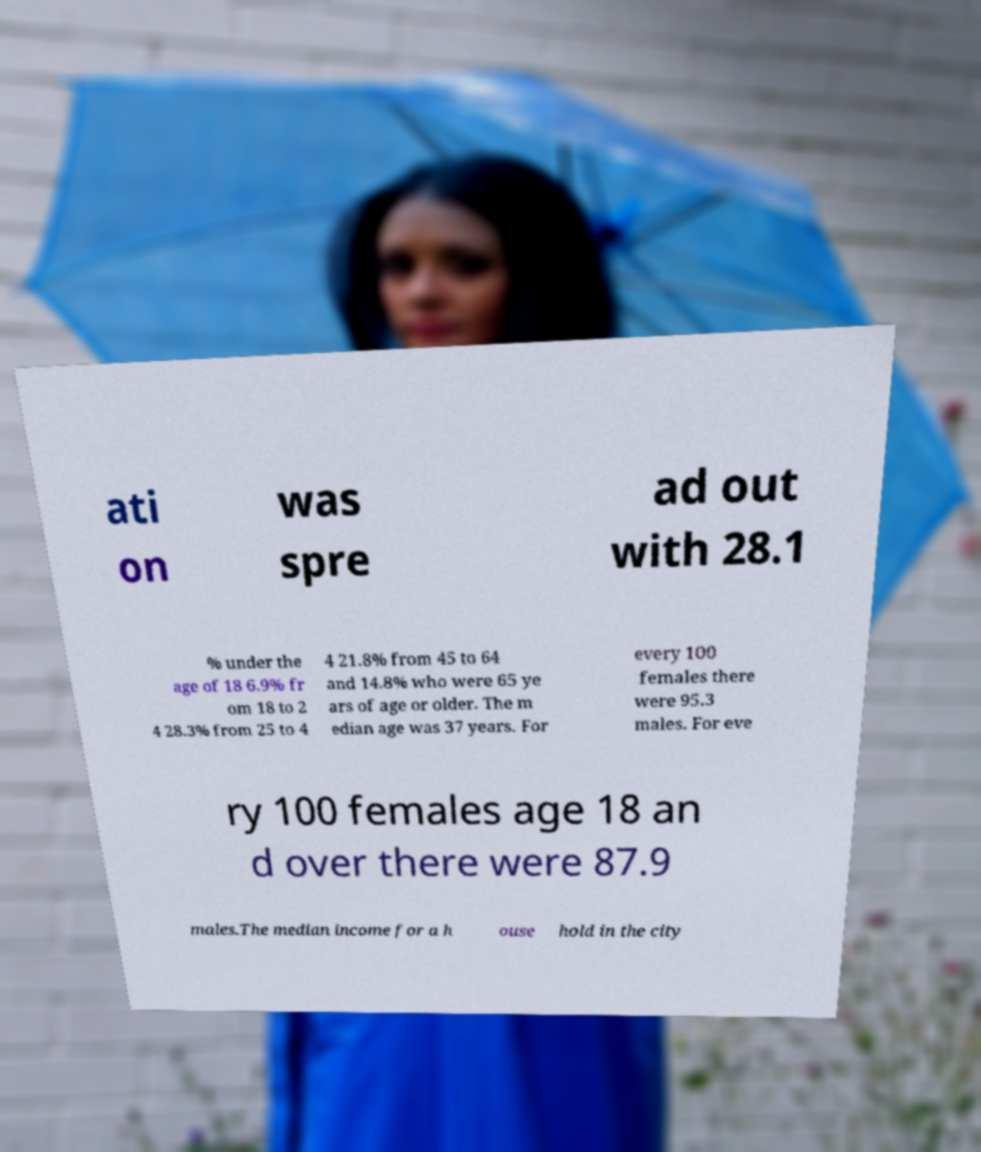Can you accurately transcribe the text from the provided image for me? ati on was spre ad out with 28.1 % under the age of 18 6.9% fr om 18 to 2 4 28.3% from 25 to 4 4 21.8% from 45 to 64 and 14.8% who were 65 ye ars of age or older. The m edian age was 37 years. For every 100 females there were 95.3 males. For eve ry 100 females age 18 an d over there were 87.9 males.The median income for a h ouse hold in the city 